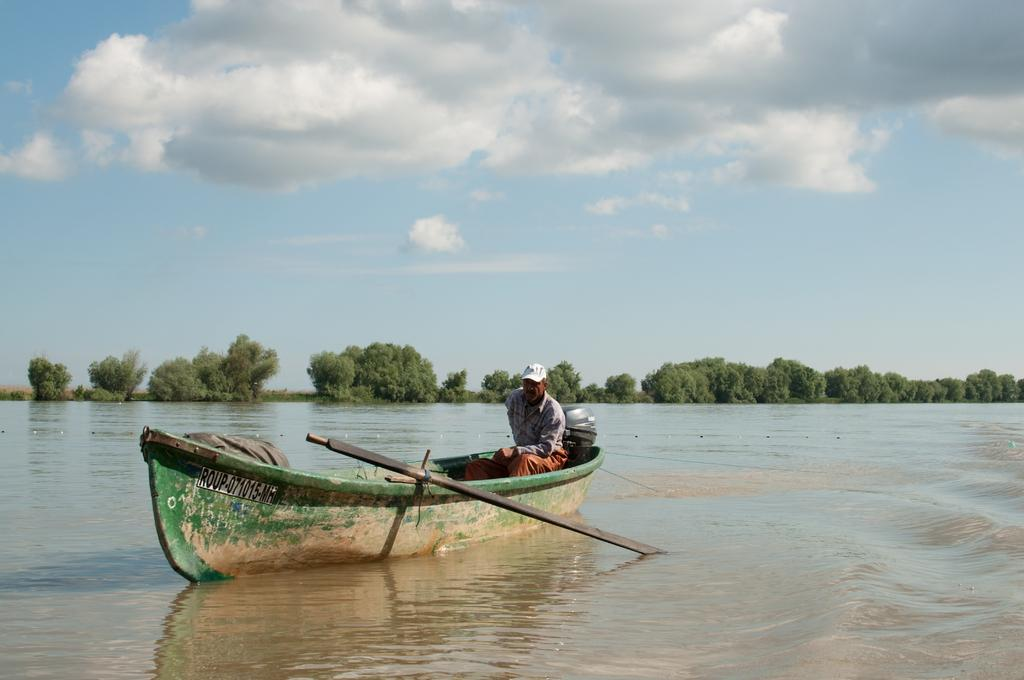Who is present in the image? There is a person in the image. What is the person doing in the image? The person is on a boat. Where is the boat located? The boat is in the river. What can be seen in the background of the image? There are trees and the sky visible in the background of the image. What type of education is the giraffe receiving on the boat in the image? There is no giraffe present in the image, and therefore no such educational activity can be observed. 